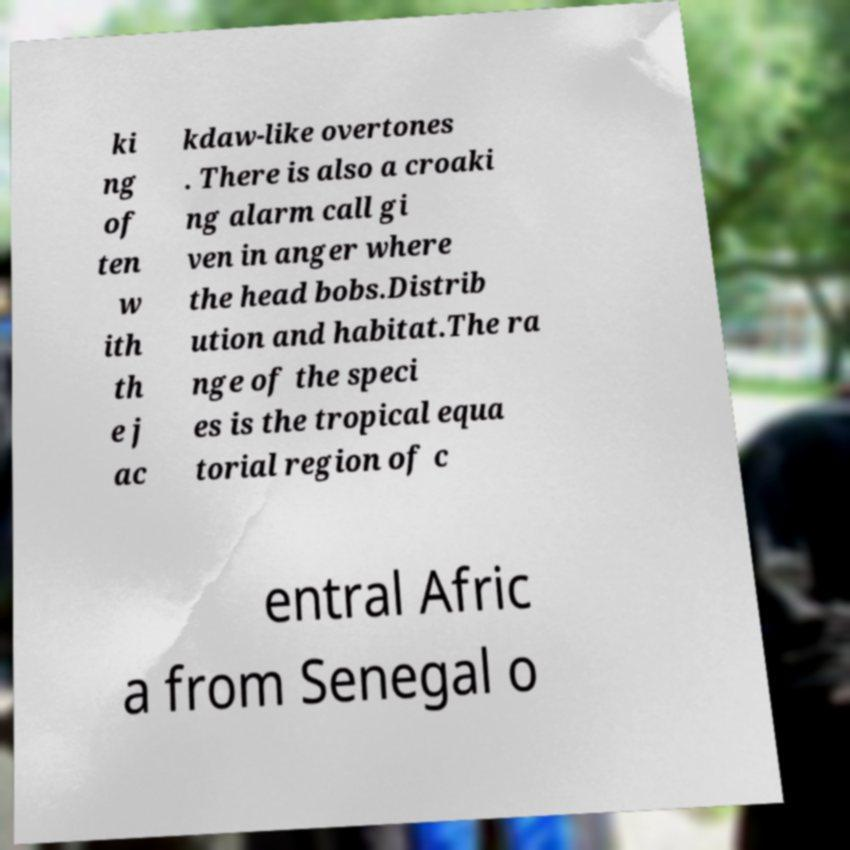Please read and relay the text visible in this image. What does it say? ki ng of ten w ith th e j ac kdaw-like overtones . There is also a croaki ng alarm call gi ven in anger where the head bobs.Distrib ution and habitat.The ra nge of the speci es is the tropical equa torial region of c entral Afric a from Senegal o 